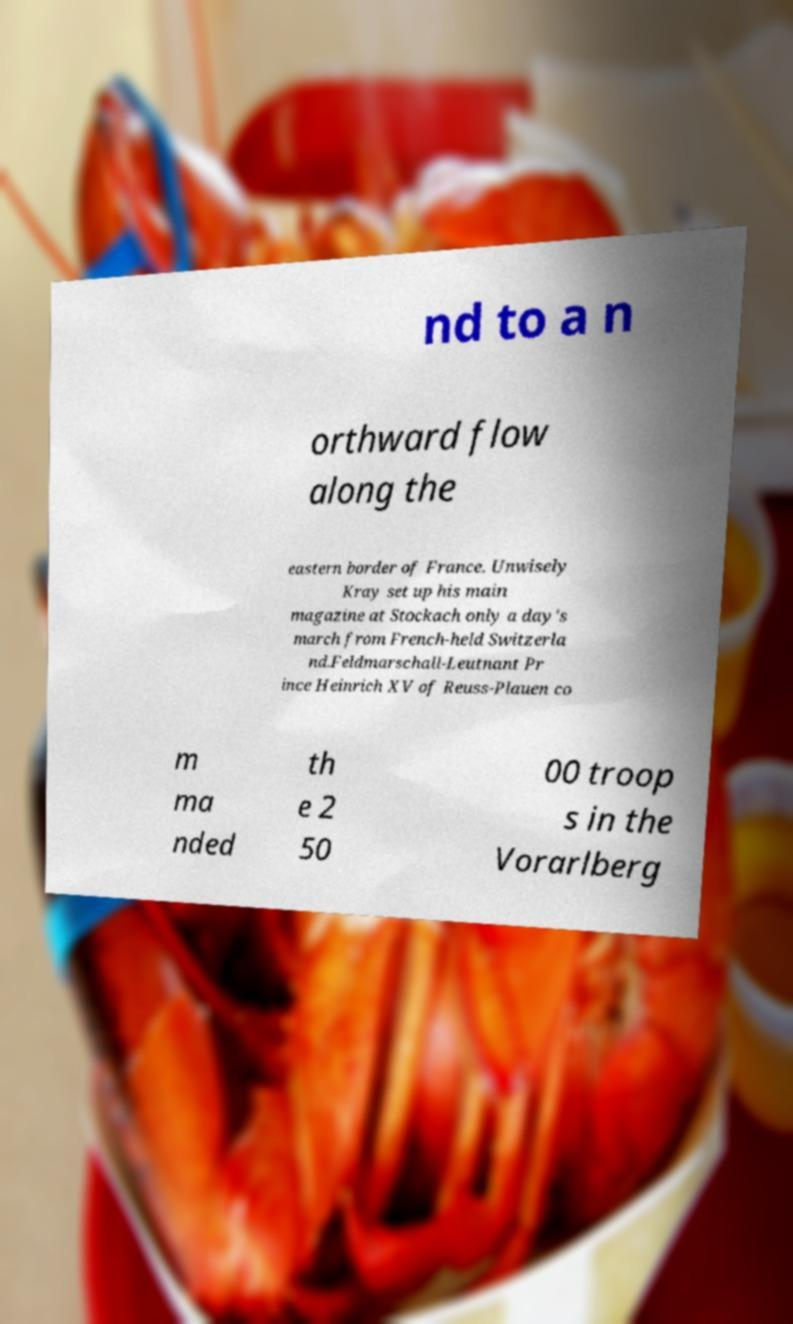Can you accurately transcribe the text from the provided image for me? nd to a n orthward flow along the eastern border of France. Unwisely Kray set up his main magazine at Stockach only a day's march from French-held Switzerla nd.Feldmarschall-Leutnant Pr ince Heinrich XV of Reuss-Plauen co m ma nded th e 2 50 00 troop s in the Vorarlberg 